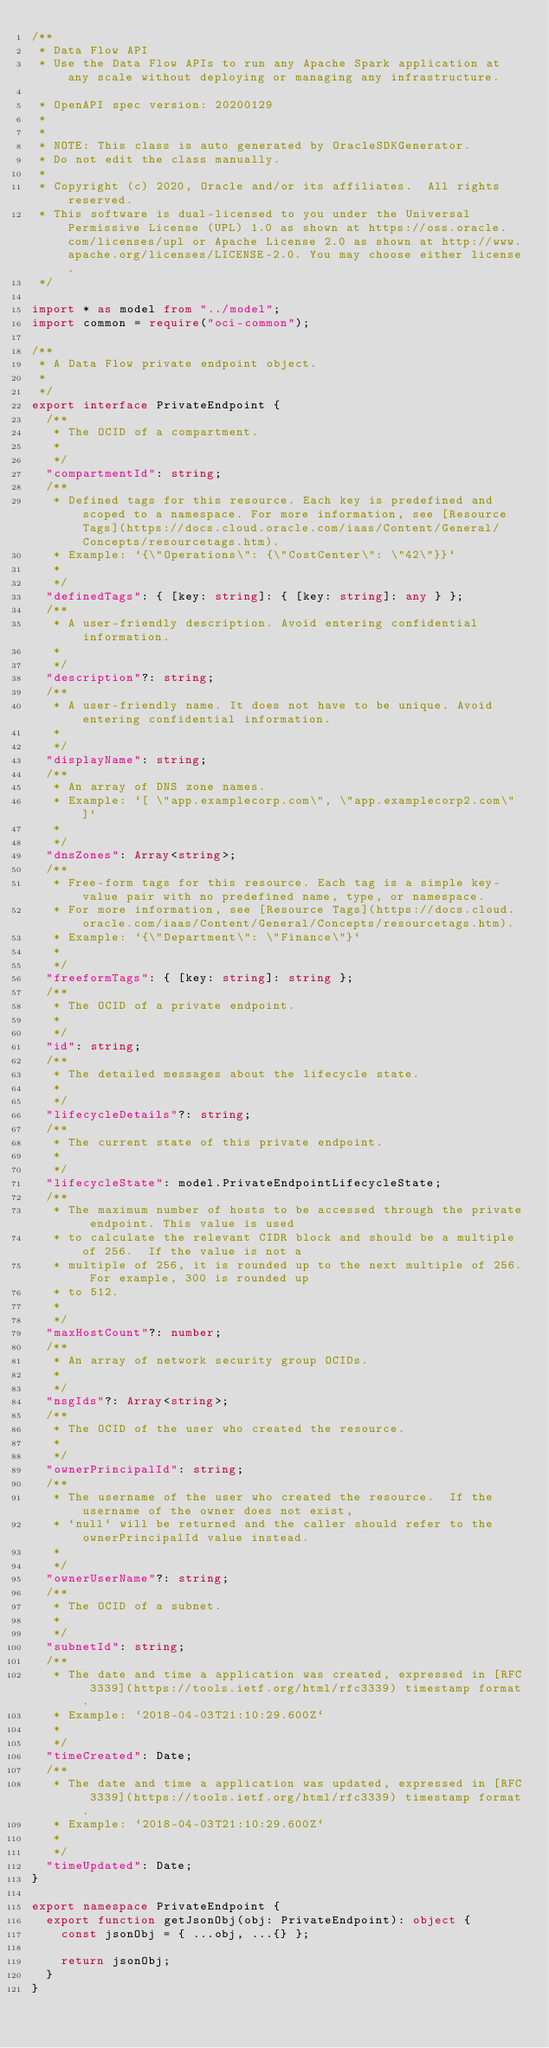Convert code to text. <code><loc_0><loc_0><loc_500><loc_500><_TypeScript_>/**
 * Data Flow API
 * Use the Data Flow APIs to run any Apache Spark application at any scale without deploying or managing any infrastructure.

 * OpenAPI spec version: 20200129
 * 
 *
 * NOTE: This class is auto generated by OracleSDKGenerator.
 * Do not edit the class manually.
 *
 * Copyright (c) 2020, Oracle and/or its affiliates.  All rights reserved.
 * This software is dual-licensed to you under the Universal Permissive License (UPL) 1.0 as shown at https://oss.oracle.com/licenses/upl or Apache License 2.0 as shown at http://www.apache.org/licenses/LICENSE-2.0. You may choose either license.
 */

import * as model from "../model";
import common = require("oci-common");

/**
 * A Data Flow private endpoint object.
 *
 */
export interface PrivateEndpoint {
  /**
   * The OCID of a compartment.
   *
   */
  "compartmentId": string;
  /**
   * Defined tags for this resource. Each key is predefined and scoped to a namespace. For more information, see [Resource Tags](https://docs.cloud.oracle.com/iaas/Content/General/Concepts/resourcetags.htm).
   * Example: `{\"Operations\": {\"CostCenter\": \"42\"}}`
   *
   */
  "definedTags": { [key: string]: { [key: string]: any } };
  /**
   * A user-friendly description. Avoid entering confidential information.
   *
   */
  "description"?: string;
  /**
   * A user-friendly name. It does not have to be unique. Avoid entering confidential information.
   *
   */
  "displayName": string;
  /**
   * An array of DNS zone names.
   * Example: `[ \"app.examplecorp.com\", \"app.examplecorp2.com\" ]`
   *
   */
  "dnsZones": Array<string>;
  /**
   * Free-form tags for this resource. Each tag is a simple key-value pair with no predefined name, type, or namespace.
   * For more information, see [Resource Tags](https://docs.cloud.oracle.com/iaas/Content/General/Concepts/resourcetags.htm).
   * Example: `{\"Department\": \"Finance\"}`
   *
   */
  "freeformTags": { [key: string]: string };
  /**
   * The OCID of a private endpoint.
   *
   */
  "id": string;
  /**
   * The detailed messages about the lifecycle state.
   *
   */
  "lifecycleDetails"?: string;
  /**
   * The current state of this private endpoint.
   *
   */
  "lifecycleState": model.PrivateEndpointLifecycleState;
  /**
   * The maximum number of hosts to be accessed through the private endpoint. This value is used
   * to calculate the relevant CIDR block and should be a multiple of 256.  If the value is not a
   * multiple of 256, it is rounded up to the next multiple of 256. For example, 300 is rounded up
   * to 512.
   *
   */
  "maxHostCount"?: number;
  /**
   * An array of network security group OCIDs.
   *
   */
  "nsgIds"?: Array<string>;
  /**
   * The OCID of the user who created the resource.
   *
   */
  "ownerPrincipalId": string;
  /**
   * The username of the user who created the resource.  If the username of the owner does not exist,
   * `null` will be returned and the caller should refer to the ownerPrincipalId value instead.
   *
   */
  "ownerUserName"?: string;
  /**
   * The OCID of a subnet.
   *
   */
  "subnetId": string;
  /**
   * The date and time a application was created, expressed in [RFC 3339](https://tools.ietf.org/html/rfc3339) timestamp format.
   * Example: `2018-04-03T21:10:29.600Z`
   *
   */
  "timeCreated": Date;
  /**
   * The date and time a application was updated, expressed in [RFC 3339](https://tools.ietf.org/html/rfc3339) timestamp format.
   * Example: `2018-04-03T21:10:29.600Z`
   *
   */
  "timeUpdated": Date;
}

export namespace PrivateEndpoint {
  export function getJsonObj(obj: PrivateEndpoint): object {
    const jsonObj = { ...obj, ...{} };

    return jsonObj;
  }
}
</code> 